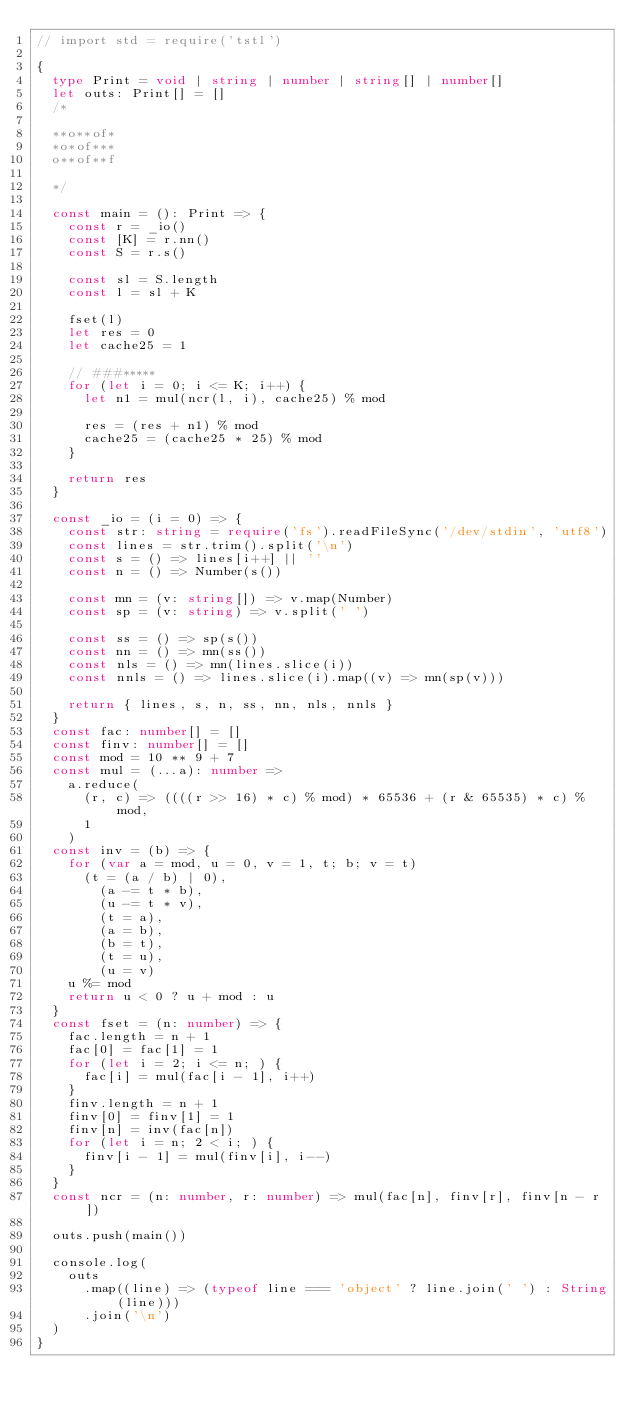<code> <loc_0><loc_0><loc_500><loc_500><_TypeScript_>// import std = require('tstl')

{
  type Print = void | string | number | string[] | number[]
  let outs: Print[] = []
  /*

  **o**of*
  *o*of***
  o**of**f
  
  */

  const main = (): Print => {
    const r = _io()
    const [K] = r.nn()
    const S = r.s()

    const sl = S.length
    const l = sl + K

    fset(l)
    let res = 0
    let cache25 = 1

    // ###*****
    for (let i = 0; i <= K; i++) {
      let n1 = mul(ncr(l, i), cache25) % mod

      res = (res + n1) % mod
      cache25 = (cache25 * 25) % mod
    }

    return res
  }

  const _io = (i = 0) => {
    const str: string = require('fs').readFileSync('/dev/stdin', 'utf8')
    const lines = str.trim().split('\n')
    const s = () => lines[i++] || ''
    const n = () => Number(s())

    const mn = (v: string[]) => v.map(Number)
    const sp = (v: string) => v.split(' ')

    const ss = () => sp(s())
    const nn = () => mn(ss())
    const nls = () => mn(lines.slice(i))
    const nnls = () => lines.slice(i).map((v) => mn(sp(v)))

    return { lines, s, n, ss, nn, nls, nnls }
  }
  const fac: number[] = []
  const finv: number[] = []
  const mod = 10 ** 9 + 7
  const mul = (...a): number =>
    a.reduce(
      (r, c) => ((((r >> 16) * c) % mod) * 65536 + (r & 65535) * c) % mod,
      1
    )
  const inv = (b) => {
    for (var a = mod, u = 0, v = 1, t; b; v = t)
      (t = (a / b) | 0),
        (a -= t * b),
        (u -= t * v),
        (t = a),
        (a = b),
        (b = t),
        (t = u),
        (u = v)
    u %= mod
    return u < 0 ? u + mod : u
  }
  const fset = (n: number) => {
    fac.length = n + 1
    fac[0] = fac[1] = 1
    for (let i = 2; i <= n; ) {
      fac[i] = mul(fac[i - 1], i++)
    }
    finv.length = n + 1
    finv[0] = finv[1] = 1
    finv[n] = inv(fac[n])
    for (let i = n; 2 < i; ) {
      finv[i - 1] = mul(finv[i], i--)
    }
  }
  const ncr = (n: number, r: number) => mul(fac[n], finv[r], finv[n - r])

  outs.push(main())

  console.log(
    outs
      .map((line) => (typeof line === 'object' ? line.join(' ') : String(line)))
      .join('\n')
  )
}
</code> 